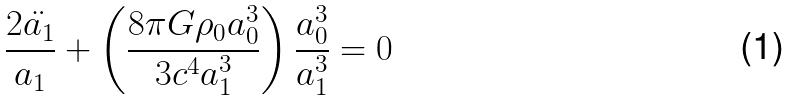<formula> <loc_0><loc_0><loc_500><loc_500>\frac { 2 \ddot { a _ { 1 } } } { a _ { 1 } } + \left ( \frac { 8 \pi G \rho _ { 0 } a _ { 0 } ^ { 3 } } { 3 c ^ { 4 } a _ { 1 } ^ { 3 } } \right ) \frac { a _ { 0 } ^ { 3 } } { a _ { 1 } ^ { 3 } } = 0</formula> 